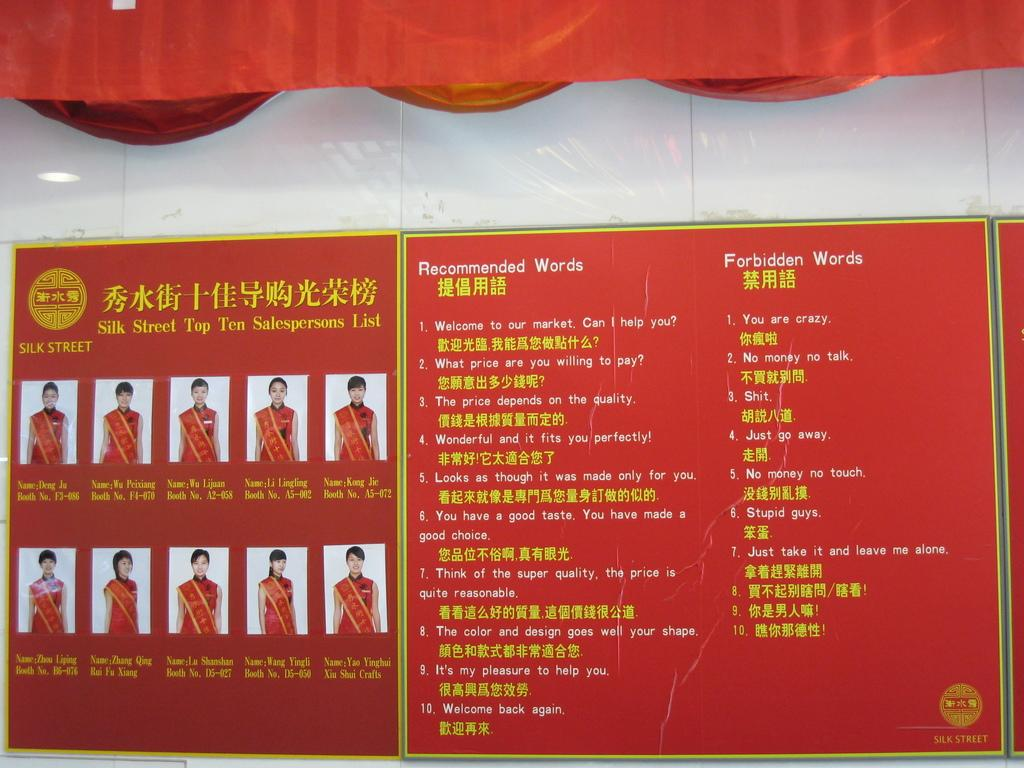Provide a one-sentence caption for the provided image. A red poster displays two lists, one of recommended words and one of forbidden words. 